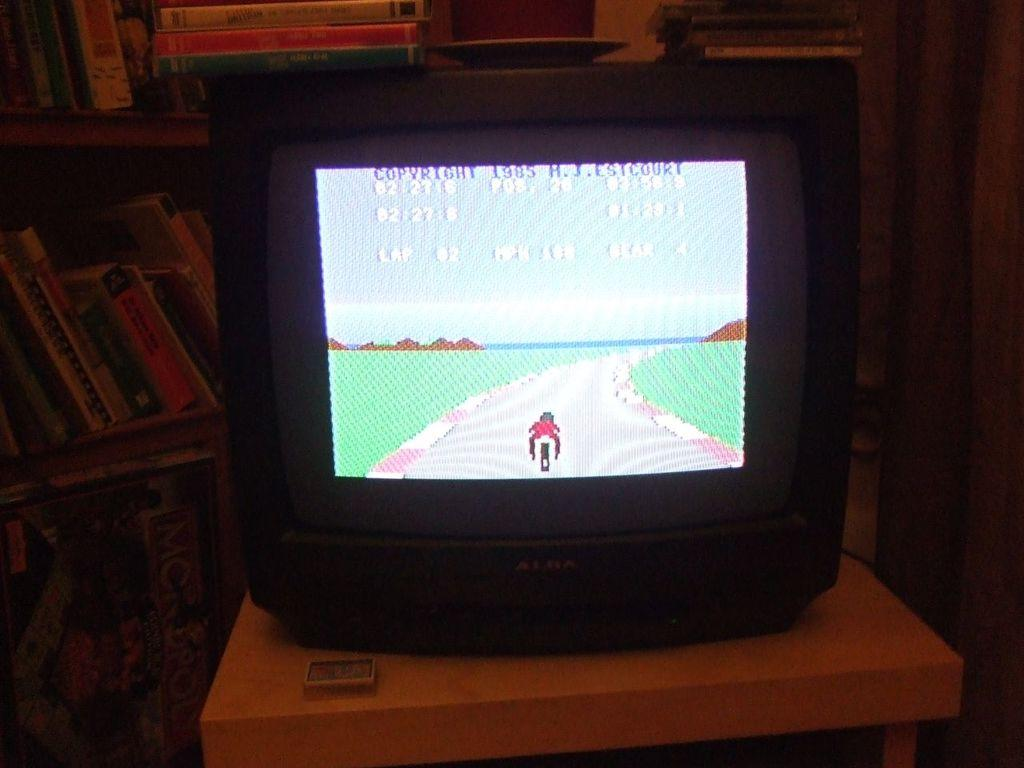<image>
Describe the image concisely. The graphics on the screen are simple from 1985. 